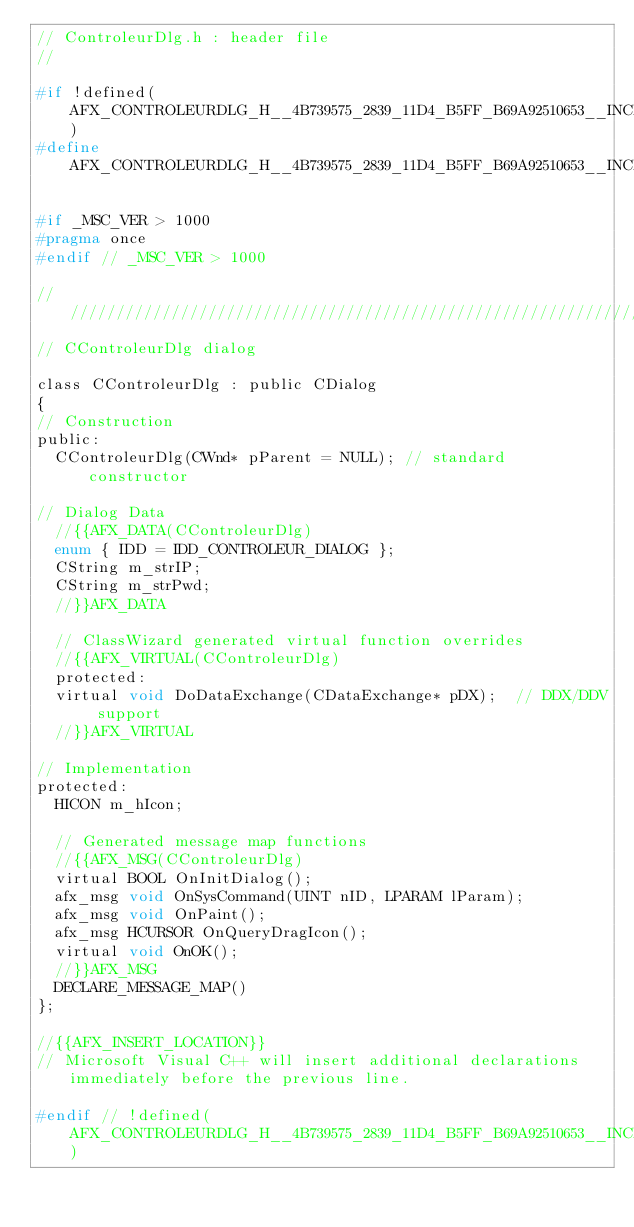Convert code to text. <code><loc_0><loc_0><loc_500><loc_500><_C_>// ControleurDlg.h : header file
//

#if !defined(AFX_CONTROLEURDLG_H__4B739575_2839_11D4_B5FF_B69A92510653__INCLUDED_)
#define AFX_CONTROLEURDLG_H__4B739575_2839_11D4_B5FF_B69A92510653__INCLUDED_

#if _MSC_VER > 1000
#pragma once
#endif // _MSC_VER > 1000

/////////////////////////////////////////////////////////////////////////////
// CControleurDlg dialog

class CControleurDlg : public CDialog
{
// Construction
public:
	CControleurDlg(CWnd* pParent = NULL);	// standard constructor

// Dialog Data
	//{{AFX_DATA(CControleurDlg)
	enum { IDD = IDD_CONTROLEUR_DIALOG };
	CString	m_strIP;
	CString	m_strPwd;
	//}}AFX_DATA

	// ClassWizard generated virtual function overrides
	//{{AFX_VIRTUAL(CControleurDlg)
	protected:
	virtual void DoDataExchange(CDataExchange* pDX);	// DDX/DDV support
	//}}AFX_VIRTUAL

// Implementation
protected:
	HICON m_hIcon;

	// Generated message map functions
	//{{AFX_MSG(CControleurDlg)
	virtual BOOL OnInitDialog();
	afx_msg void OnSysCommand(UINT nID, LPARAM lParam);
	afx_msg void OnPaint();
	afx_msg HCURSOR OnQueryDragIcon();
	virtual void OnOK();
	//}}AFX_MSG
	DECLARE_MESSAGE_MAP()
};

//{{AFX_INSERT_LOCATION}}
// Microsoft Visual C++ will insert additional declarations immediately before the previous line.

#endif // !defined(AFX_CONTROLEURDLG_H__4B739575_2839_11D4_B5FF_B69A92510653__INCLUDED_)
</code> 